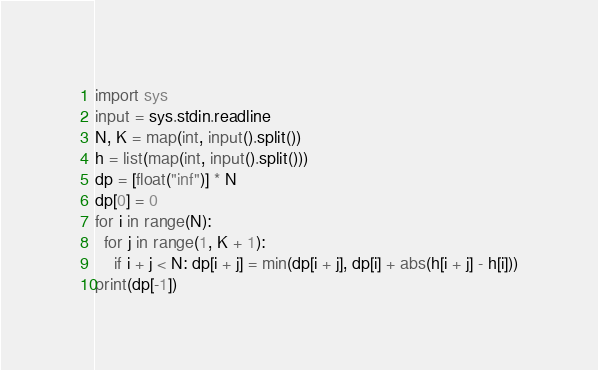<code> <loc_0><loc_0><loc_500><loc_500><_Python_>import sys
input = sys.stdin.readline
N, K = map(int, input().split())
h = list(map(int, input().split()))
dp = [float("inf")] * N
dp[0] = 0
for i in range(N):
  for j in range(1, K + 1):
    if i + j < N: dp[i + j] = min(dp[i + j], dp[i] + abs(h[i + j] - h[i]))
print(dp[-1])</code> 